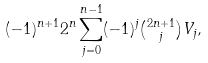Convert formula to latex. <formula><loc_0><loc_0><loc_500><loc_500>( - 1 ) ^ { n + 1 } 2 ^ { n } \sum _ { j = 0 } ^ { n - 1 } ( - 1 ) ^ { j } \tbinom { 2 n + 1 } j V _ { j } ,</formula> 